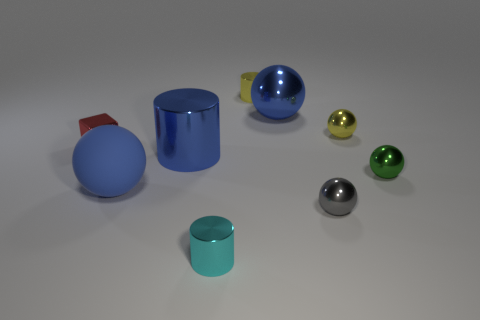Subtract all purple blocks. How many blue balls are left? 2 Subtract all rubber spheres. How many spheres are left? 4 Subtract 1 balls. How many balls are left? 4 Subtract all green balls. How many balls are left? 4 Subtract all purple balls. Subtract all green cylinders. How many balls are left? 5 Subtract all cylinders. How many objects are left? 6 Add 5 large green cylinders. How many large green cylinders exist? 5 Subtract 0 gray cylinders. How many objects are left? 9 Subtract all blue metallic objects. Subtract all big balls. How many objects are left? 5 Add 1 red shiny cubes. How many red shiny cubes are left? 2 